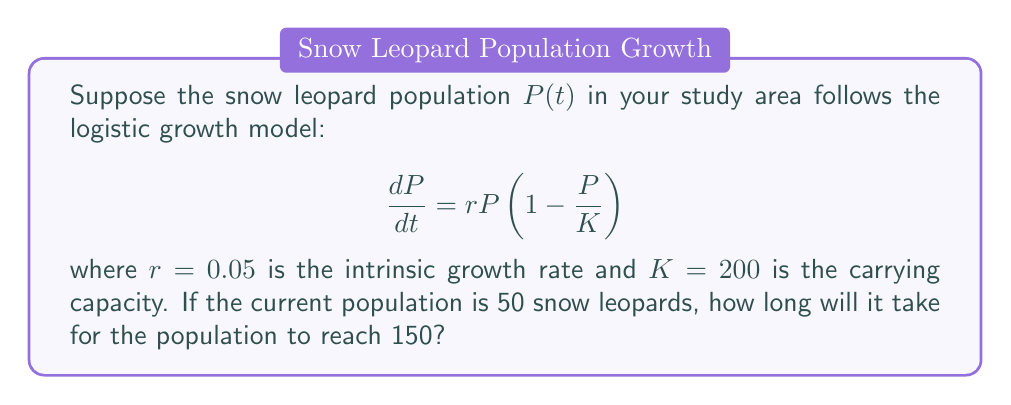Give your solution to this math problem. To solve this problem, we'll follow these steps:

1) The logistic growth model is given by the differential equation:

   $$\frac{dP}{dt} = rP\left(1 - \frac{P}{K}\right)$$

2) The solution to this differential equation is:

   $$P(t) = \frac{K}{1 + \left(\frac{K}{P_0} - 1\right)e^{-rt}}$$

   where $P_0$ is the initial population.

3) We're given:
   $r = 0.05$
   $K = 200$
   $P_0 = 50$
   We need to find $t$ when $P(t) = 150$

4) Substituting these values into the equation:

   $$150 = \frac{200}{1 + \left(\frac{200}{50} - 1\right)e^{-0.05t}}$$

5) Simplify:

   $$150 = \frac{200}{1 + 3e^{-0.05t}}$$

6) Multiply both sides by $(1 + 3e^{-0.05t})$:

   $$150(1 + 3e^{-0.05t}) = 200$$

7) Expand:

   $$150 + 450e^{-0.05t} = 200$$

8) Subtract 150 from both sides:

   $$450e^{-0.05t} = 50$$

9) Divide both sides by 450:

   $$e^{-0.05t} = \frac{1}{9}$$

10) Take the natural log of both sides:

    $$-0.05t = \ln\left(\frac{1}{9}\right)$$

11) Divide both sides by -0.05:

    $$t = -\frac{\ln\left(\frac{1}{9}\right)}{0.05}$$

12) Simplify:

    $$t = \frac{\ln(9)}{0.05} \approx 44.36$$

Therefore, it will take approximately 44.36 years for the snow leopard population to reach 150.
Answer: $44.36$ years 